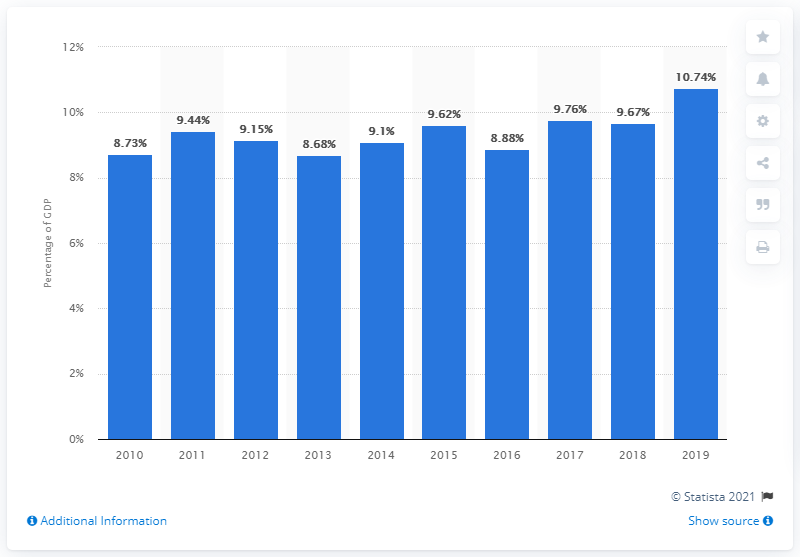Specify some key components in this picture. In 2019, the travel and tourism sector contributed 10.74% to the gross domestic product of Saint Kitts and Nevis. 